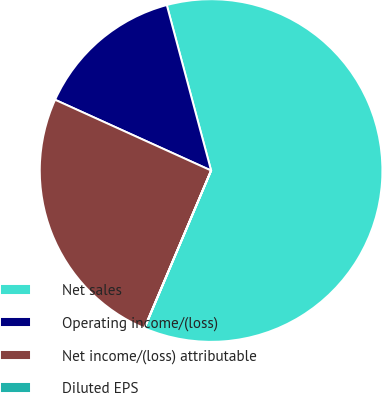Convert chart. <chart><loc_0><loc_0><loc_500><loc_500><pie_chart><fcel>Net sales<fcel>Operating income/(loss)<fcel>Net income/(loss) attributable<fcel>Diluted EPS<nl><fcel>60.53%<fcel>14.06%<fcel>25.4%<fcel>0.02%<nl></chart> 